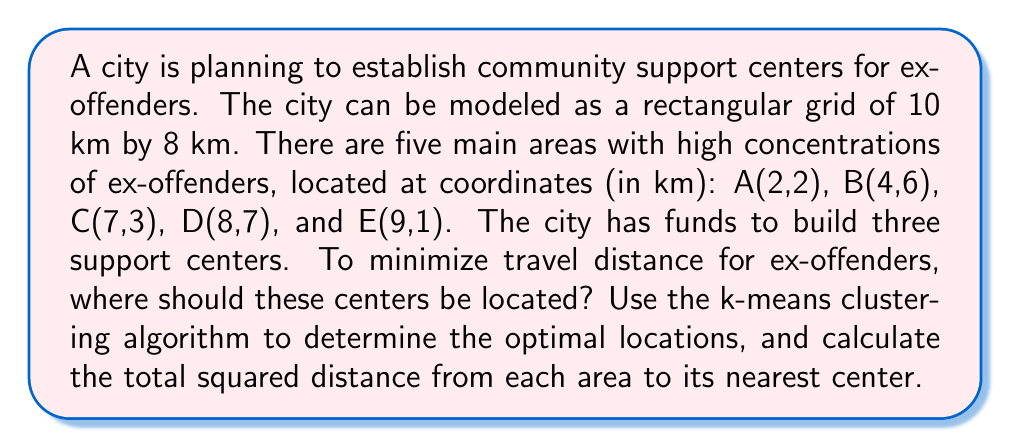Solve this math problem. To solve this problem, we'll use the k-means clustering algorithm with k=3. This will help us determine the optimal locations for the three support centers.

Step 1: Initialize cluster centers
Let's start with random initial centers:
C1(3,3), C2(6,5), C3(8,4)

Step 2: Assign each point to the nearest center
Calculate distances from each point to each center:

$$d(P,C) = \sqrt{(x_P-x_C)^2 + (y_P-y_C)^2}$$

Assign each point to the nearest center:
A → C1, B → C2, C → C3, D → C2, E → C3

Step 3: Recalculate center positions
New C1 = (2,2)
New C2 = ((4+8)/2, (6+7)/2) = (6,6.5)
New C3 = ((7+9)/2, (3+1)/2) = (8,2)

Step 4: Repeat steps 2-3 until convergence
After a few iterations, we reach convergence with:
C1(2,2), C2(6,6.5), C3(8,2)

Final assignments:
A → C1, B → C2, C → C3, D → C2, E → C3

Step 5: Calculate total squared distance
For each point, calculate the squared distance to its assigned center:

$$d^2(A,C1) = (2-2)^2 + (2-2)^2 = 0$$
$$d^2(B,C2) = (4-6)^2 + (6-6.5)^2 = 4.25$$
$$d^2(C,C3) = (7-8)^2 + (3-2)^2 = 2$$
$$d^2(D,C2) = (8-6)^2 + (7-6.5)^2 = 4.25$$
$$d^2(E,C3) = (9-8)^2 + (1-2)^2 = 2$$

Total squared distance = 0 + 4.25 + 2 + 4.25 + 2 = 12.5 km²
Answer: The optimal locations for the three support centers are (2,2), (6,6.5), and (8,2). The total squared distance from each area to its nearest center is 12.5 km². 